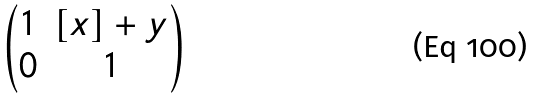Convert formula to latex. <formula><loc_0><loc_0><loc_500><loc_500>\begin{pmatrix} 1 & [ x ] + y \\ 0 & 1 \end{pmatrix}</formula> 